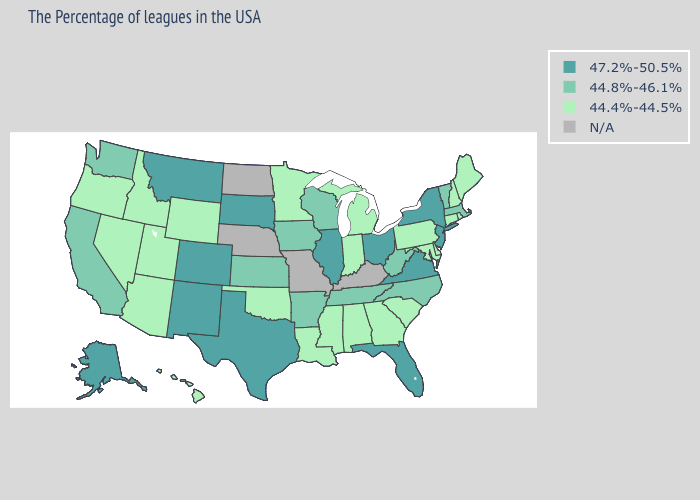Among the states that border Rhode Island , does Connecticut have the lowest value?
Answer briefly. Yes. What is the value of Pennsylvania?
Be succinct. 44.4%-44.5%. Does the first symbol in the legend represent the smallest category?
Short answer required. No. What is the value of Washington?
Write a very short answer. 44.8%-46.1%. Name the states that have a value in the range 44.4%-44.5%?
Concise answer only. Maine, Rhode Island, New Hampshire, Connecticut, Delaware, Maryland, Pennsylvania, South Carolina, Georgia, Michigan, Indiana, Alabama, Mississippi, Louisiana, Minnesota, Oklahoma, Wyoming, Utah, Arizona, Idaho, Nevada, Oregon, Hawaii. Does the map have missing data?
Concise answer only. Yes. Which states have the highest value in the USA?
Keep it brief. New York, New Jersey, Virginia, Ohio, Florida, Illinois, Texas, South Dakota, Colorado, New Mexico, Montana, Alaska. What is the value of Montana?
Answer briefly. 47.2%-50.5%. Which states hav the highest value in the West?
Give a very brief answer. Colorado, New Mexico, Montana, Alaska. What is the value of South Carolina?
Give a very brief answer. 44.4%-44.5%. Name the states that have a value in the range 44.8%-46.1%?
Write a very short answer. Massachusetts, Vermont, North Carolina, West Virginia, Tennessee, Wisconsin, Arkansas, Iowa, Kansas, California, Washington. What is the value of Missouri?
Keep it brief. N/A. What is the value of New Jersey?
Write a very short answer. 47.2%-50.5%. Does the first symbol in the legend represent the smallest category?
Quick response, please. No. How many symbols are there in the legend?
Quick response, please. 4. 